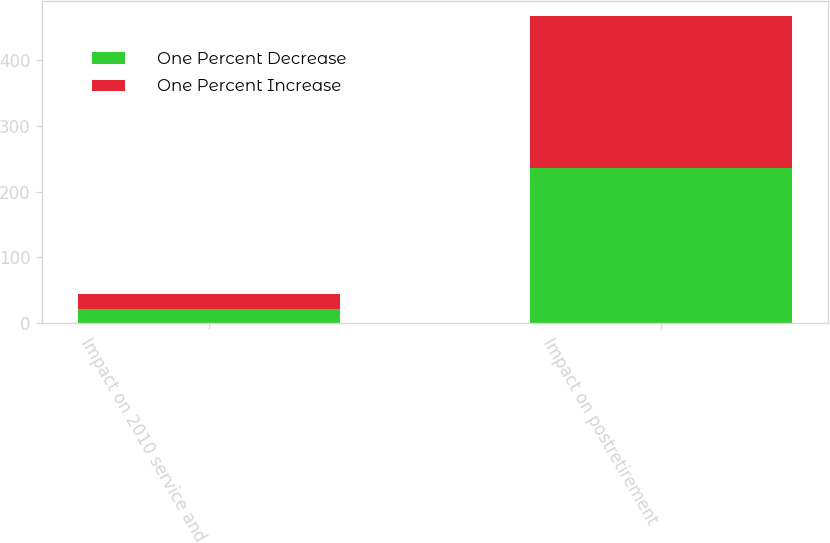<chart> <loc_0><loc_0><loc_500><loc_500><stacked_bar_chart><ecel><fcel>Impact on 2010 service and<fcel>Impact on postretirement<nl><fcel>One Percent Decrease<fcel>22<fcel>235<nl><fcel>One Percent Increase<fcel>22<fcel>231<nl></chart> 